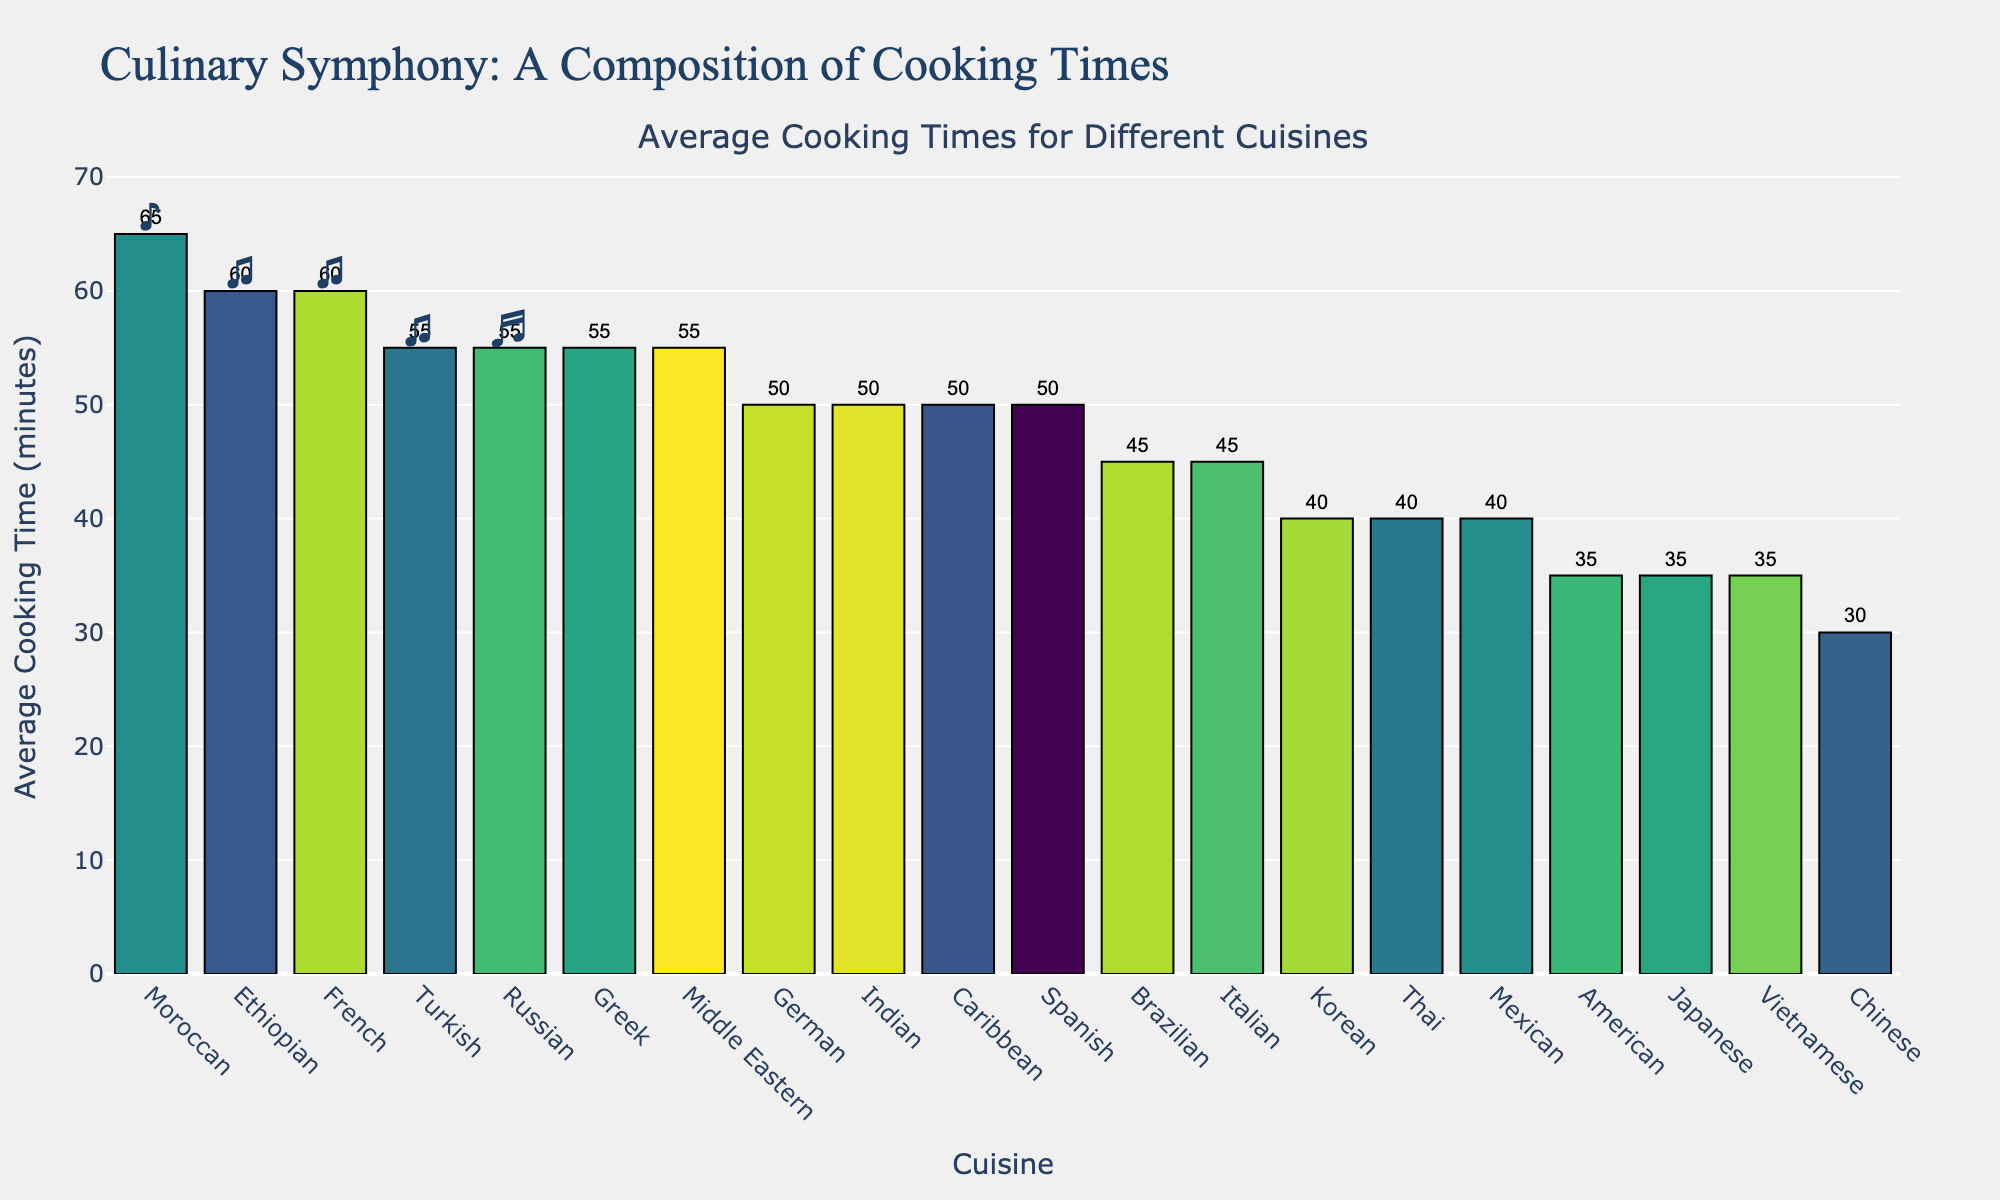Which cuisine has the longest average cooking time? Look at the bar with the maximum height in the chart, which represents the longest cooking time. The tallest bar corresponds to Moroccan cuisine.
Answer: Moroccan Which cuisine has the shortest average cooking time? Find the bar with the minimum height, representing the shortest cooking time. The shortest bar corresponds to Chinese cuisine.
Answer: Chinese How much longer, on average, does it take to cook French cuisine compared to Japanese cuisine? Find the heights representing French and Japanese cuisines, and calculate the difference: 60 (French) - 35 (Japanese) = 25 minutes.
Answer: 25 minutes Which cuisines have an average cooking time equal to 50 minutes? Identify the bars that correspond to a height of 50 minutes. These are Indian, Spanish, Korean, German, and Caribbean cuisines.
Answer: Indian, Spanish, Korean, German, Caribbean What is the combined average cooking time for Italian and Brazilian cuisines? Find the heights representing Italian and Brazilian cuisines, and sum them: 45 (Italian) + 45 (Brazilian) = 90 minutes.
Answer: 90 minutes Which cuisines have the same average cooking time of 55 minutes? Locate the bars with a height of 55 minutes, which are Greek, Middle Eastern, Russian, and Turkish cuisines.
Answer: Greek, Middle Eastern, Russian, Turkish What is the difference in average cooking times between Ethiopian and Italian cuisines? Calculate the difference between the heights of Ethiopian and Italian cuisine bars: 60 (Ethiopian) - 45 (Italian) = 15 minutes.
Answer: 15 minutes How many cuisines have an average cooking time of 35 minutes? Count all bars that have a height of 35 minutes. There are three such bars: Japanese, Vietnamese, and American cuisines.
Answer: 3 Which cuisine has an average cooking time that is closest to the median average cooking time of all cuisines? Sort the average cooking times and find the median (middle value) which is 50 minutes. The cuisines closest to 50 minutes are Indian, Spanish, Korean, German, and Caribbean cuisines.
Answer: Indian, Spanish, Korean, German, Caribbean Of the top 5 longest average cooking times, which cuisine ranks fourth? Order the top 5 longest cooking times: 65 (Moroccan), 60 (French), 60 (Ethiopian), 55 (Greek), and 55 (Middle Eastern). The fourth cuisine is Greek (55 minutes).
Answer: Greek 